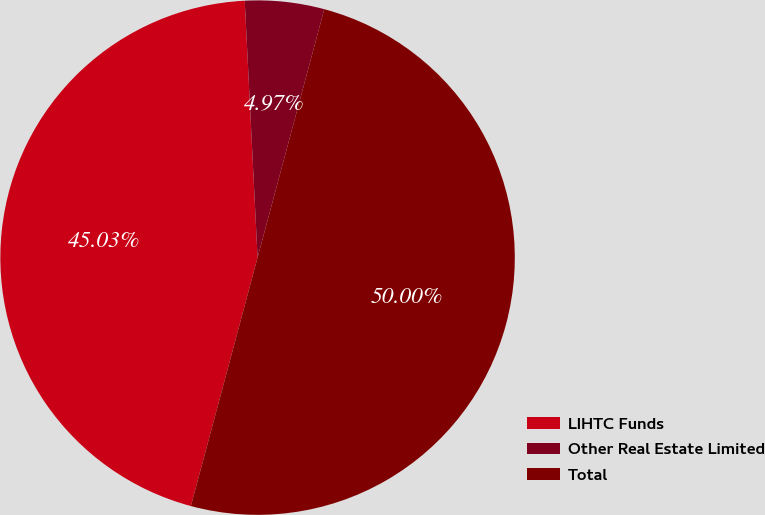<chart> <loc_0><loc_0><loc_500><loc_500><pie_chart><fcel>LIHTC Funds<fcel>Other Real Estate Limited<fcel>Total<nl><fcel>45.03%<fcel>4.97%<fcel>50.0%<nl></chart> 